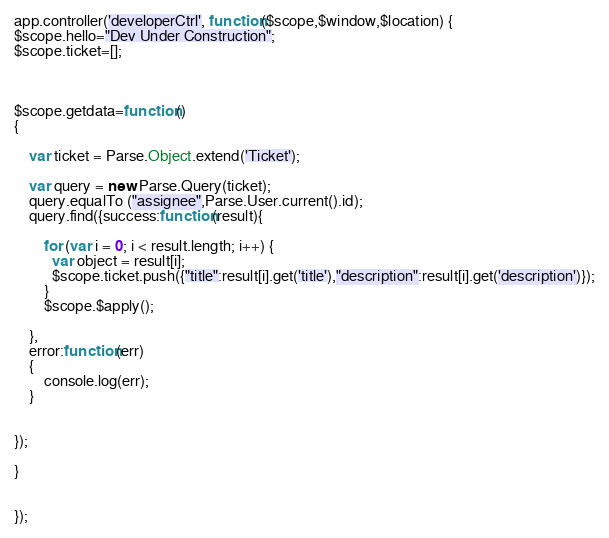<code> <loc_0><loc_0><loc_500><loc_500><_JavaScript_>app.controller('developerCtrl', function($scope,$window,$location) {
$scope.hello="Dev Under Construction";
$scope.ticket=[];



$scope.getdata=function()
{

	var ticket = Parse.Object.extend('Ticket');

    var query = new Parse.Query(ticket);
    query.equalTo ("assignee",Parse.User.current().id);
    query.find({success:function(result){

    	for (var i = 0; i < result.length; i++) {
          var object = result[i];
          $scope.ticket.push({"title":result[i].get('title'),"description":result[i].get('description')});
        }
        $scope.$apply();
        
    },
    error:function(err)
    {
    	console.log(err);
    }


});

}


});</code> 